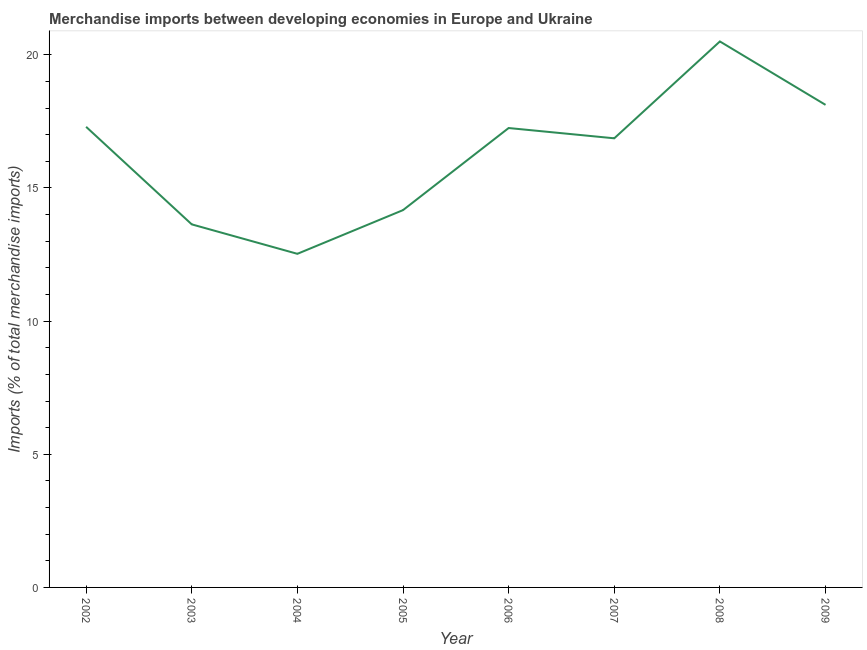What is the merchandise imports in 2009?
Ensure brevity in your answer.  18.12. Across all years, what is the maximum merchandise imports?
Your answer should be very brief. 20.5. Across all years, what is the minimum merchandise imports?
Your response must be concise. 12.53. In which year was the merchandise imports minimum?
Provide a short and direct response. 2004. What is the sum of the merchandise imports?
Keep it short and to the point. 130.36. What is the difference between the merchandise imports in 2006 and 2007?
Your answer should be compact. 0.39. What is the average merchandise imports per year?
Ensure brevity in your answer.  16.29. What is the median merchandise imports?
Provide a short and direct response. 17.06. Do a majority of the years between 2006 and 2007 (inclusive) have merchandise imports greater than 9 %?
Give a very brief answer. Yes. What is the ratio of the merchandise imports in 2003 to that in 2004?
Provide a short and direct response. 1.09. Is the merchandise imports in 2002 less than that in 2008?
Your answer should be very brief. Yes. What is the difference between the highest and the second highest merchandise imports?
Offer a terse response. 2.38. What is the difference between the highest and the lowest merchandise imports?
Your answer should be compact. 7.97. In how many years, is the merchandise imports greater than the average merchandise imports taken over all years?
Ensure brevity in your answer.  5. Does the merchandise imports monotonically increase over the years?
Your answer should be very brief. No. How many lines are there?
Your answer should be compact. 1. How many years are there in the graph?
Provide a short and direct response. 8. Does the graph contain any zero values?
Offer a very short reply. No. Does the graph contain grids?
Give a very brief answer. No. What is the title of the graph?
Ensure brevity in your answer.  Merchandise imports between developing economies in Europe and Ukraine. What is the label or title of the X-axis?
Your answer should be very brief. Year. What is the label or title of the Y-axis?
Give a very brief answer. Imports (% of total merchandise imports). What is the Imports (% of total merchandise imports) in 2002?
Provide a short and direct response. 17.3. What is the Imports (% of total merchandise imports) in 2003?
Provide a short and direct response. 13.63. What is the Imports (% of total merchandise imports) of 2004?
Your answer should be very brief. 12.53. What is the Imports (% of total merchandise imports) in 2005?
Your answer should be compact. 14.17. What is the Imports (% of total merchandise imports) in 2006?
Provide a succinct answer. 17.25. What is the Imports (% of total merchandise imports) in 2007?
Your answer should be very brief. 16.86. What is the Imports (% of total merchandise imports) in 2008?
Offer a terse response. 20.5. What is the Imports (% of total merchandise imports) of 2009?
Provide a succinct answer. 18.12. What is the difference between the Imports (% of total merchandise imports) in 2002 and 2003?
Ensure brevity in your answer.  3.66. What is the difference between the Imports (% of total merchandise imports) in 2002 and 2004?
Ensure brevity in your answer.  4.77. What is the difference between the Imports (% of total merchandise imports) in 2002 and 2005?
Offer a terse response. 3.13. What is the difference between the Imports (% of total merchandise imports) in 2002 and 2006?
Offer a very short reply. 0.05. What is the difference between the Imports (% of total merchandise imports) in 2002 and 2007?
Make the answer very short. 0.43. What is the difference between the Imports (% of total merchandise imports) in 2002 and 2008?
Give a very brief answer. -3.21. What is the difference between the Imports (% of total merchandise imports) in 2002 and 2009?
Your answer should be compact. -0.82. What is the difference between the Imports (% of total merchandise imports) in 2003 and 2004?
Make the answer very short. 1.11. What is the difference between the Imports (% of total merchandise imports) in 2003 and 2005?
Offer a very short reply. -0.53. What is the difference between the Imports (% of total merchandise imports) in 2003 and 2006?
Your response must be concise. -3.62. What is the difference between the Imports (% of total merchandise imports) in 2003 and 2007?
Offer a very short reply. -3.23. What is the difference between the Imports (% of total merchandise imports) in 2003 and 2008?
Offer a very short reply. -6.87. What is the difference between the Imports (% of total merchandise imports) in 2003 and 2009?
Give a very brief answer. -4.49. What is the difference between the Imports (% of total merchandise imports) in 2004 and 2005?
Provide a short and direct response. -1.64. What is the difference between the Imports (% of total merchandise imports) in 2004 and 2006?
Ensure brevity in your answer.  -4.72. What is the difference between the Imports (% of total merchandise imports) in 2004 and 2007?
Make the answer very short. -4.34. What is the difference between the Imports (% of total merchandise imports) in 2004 and 2008?
Ensure brevity in your answer.  -7.97. What is the difference between the Imports (% of total merchandise imports) in 2004 and 2009?
Your answer should be compact. -5.59. What is the difference between the Imports (% of total merchandise imports) in 2005 and 2006?
Your response must be concise. -3.08. What is the difference between the Imports (% of total merchandise imports) in 2005 and 2007?
Offer a very short reply. -2.7. What is the difference between the Imports (% of total merchandise imports) in 2005 and 2008?
Give a very brief answer. -6.33. What is the difference between the Imports (% of total merchandise imports) in 2005 and 2009?
Your answer should be compact. -3.95. What is the difference between the Imports (% of total merchandise imports) in 2006 and 2007?
Provide a short and direct response. 0.39. What is the difference between the Imports (% of total merchandise imports) in 2006 and 2008?
Ensure brevity in your answer.  -3.25. What is the difference between the Imports (% of total merchandise imports) in 2006 and 2009?
Your response must be concise. -0.87. What is the difference between the Imports (% of total merchandise imports) in 2007 and 2008?
Ensure brevity in your answer.  -3.64. What is the difference between the Imports (% of total merchandise imports) in 2007 and 2009?
Provide a short and direct response. -1.26. What is the difference between the Imports (% of total merchandise imports) in 2008 and 2009?
Offer a terse response. 2.38. What is the ratio of the Imports (% of total merchandise imports) in 2002 to that in 2003?
Give a very brief answer. 1.27. What is the ratio of the Imports (% of total merchandise imports) in 2002 to that in 2004?
Make the answer very short. 1.38. What is the ratio of the Imports (% of total merchandise imports) in 2002 to that in 2005?
Offer a terse response. 1.22. What is the ratio of the Imports (% of total merchandise imports) in 2002 to that in 2006?
Keep it short and to the point. 1. What is the ratio of the Imports (% of total merchandise imports) in 2002 to that in 2007?
Offer a terse response. 1.03. What is the ratio of the Imports (% of total merchandise imports) in 2002 to that in 2008?
Provide a short and direct response. 0.84. What is the ratio of the Imports (% of total merchandise imports) in 2002 to that in 2009?
Keep it short and to the point. 0.95. What is the ratio of the Imports (% of total merchandise imports) in 2003 to that in 2004?
Your response must be concise. 1.09. What is the ratio of the Imports (% of total merchandise imports) in 2003 to that in 2006?
Provide a succinct answer. 0.79. What is the ratio of the Imports (% of total merchandise imports) in 2003 to that in 2007?
Your response must be concise. 0.81. What is the ratio of the Imports (% of total merchandise imports) in 2003 to that in 2008?
Offer a terse response. 0.67. What is the ratio of the Imports (% of total merchandise imports) in 2003 to that in 2009?
Provide a succinct answer. 0.75. What is the ratio of the Imports (% of total merchandise imports) in 2004 to that in 2005?
Offer a terse response. 0.88. What is the ratio of the Imports (% of total merchandise imports) in 2004 to that in 2006?
Provide a succinct answer. 0.73. What is the ratio of the Imports (% of total merchandise imports) in 2004 to that in 2007?
Offer a very short reply. 0.74. What is the ratio of the Imports (% of total merchandise imports) in 2004 to that in 2008?
Provide a short and direct response. 0.61. What is the ratio of the Imports (% of total merchandise imports) in 2004 to that in 2009?
Offer a terse response. 0.69. What is the ratio of the Imports (% of total merchandise imports) in 2005 to that in 2006?
Offer a very short reply. 0.82. What is the ratio of the Imports (% of total merchandise imports) in 2005 to that in 2007?
Make the answer very short. 0.84. What is the ratio of the Imports (% of total merchandise imports) in 2005 to that in 2008?
Your answer should be compact. 0.69. What is the ratio of the Imports (% of total merchandise imports) in 2005 to that in 2009?
Your answer should be compact. 0.78. What is the ratio of the Imports (% of total merchandise imports) in 2006 to that in 2007?
Make the answer very short. 1.02. What is the ratio of the Imports (% of total merchandise imports) in 2006 to that in 2008?
Offer a terse response. 0.84. What is the ratio of the Imports (% of total merchandise imports) in 2006 to that in 2009?
Your answer should be compact. 0.95. What is the ratio of the Imports (% of total merchandise imports) in 2007 to that in 2008?
Provide a succinct answer. 0.82. What is the ratio of the Imports (% of total merchandise imports) in 2007 to that in 2009?
Give a very brief answer. 0.93. What is the ratio of the Imports (% of total merchandise imports) in 2008 to that in 2009?
Your response must be concise. 1.13. 